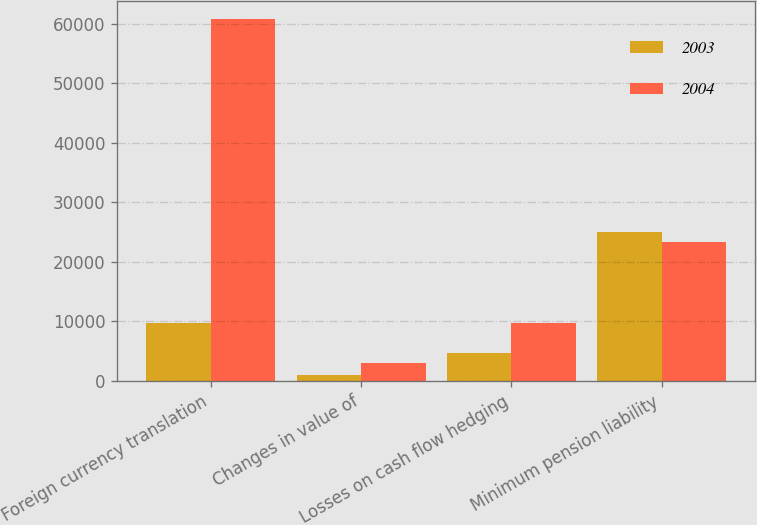Convert chart. <chart><loc_0><loc_0><loc_500><loc_500><stacked_bar_chart><ecel><fcel>Foreign currency translation<fcel>Changes in value of<fcel>Losses on cash flow hedging<fcel>Minimum pension liability<nl><fcel>2003<fcel>9774<fcel>962<fcel>4617<fcel>25042<nl><fcel>2004<fcel>60694<fcel>2945<fcel>9774<fcel>23381<nl></chart> 